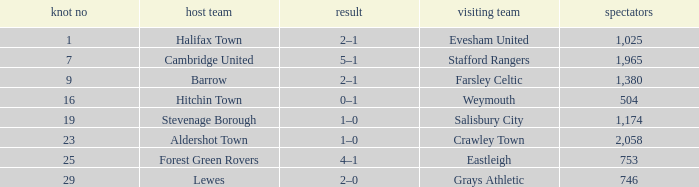What is the highest attendance for games with stevenage borough at home? 1174.0. 